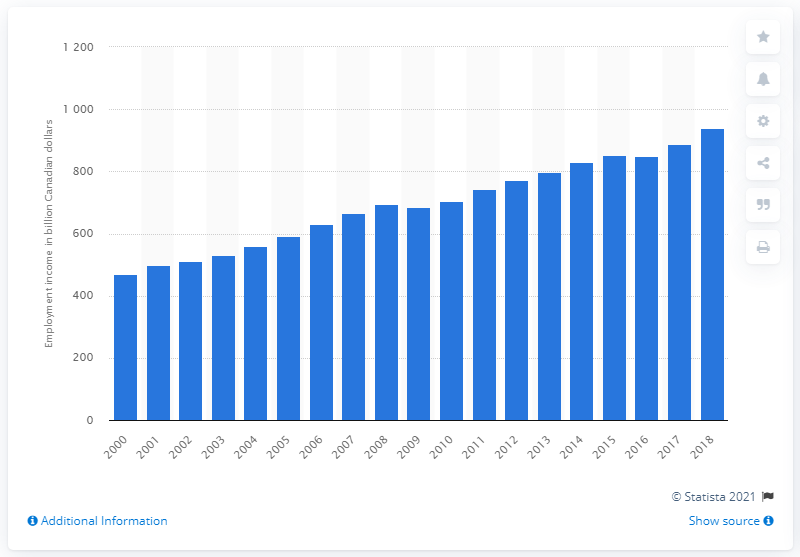Draw attention to some important aspects in this diagram. In 2018, the total amount of Canadian dollars earned by Canadian tax filers was CAD 938.5. 